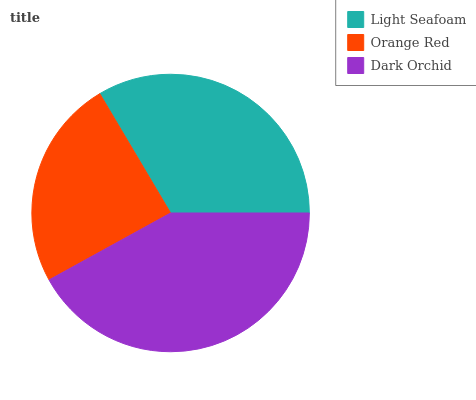Is Orange Red the minimum?
Answer yes or no. Yes. Is Dark Orchid the maximum?
Answer yes or no. Yes. Is Dark Orchid the minimum?
Answer yes or no. No. Is Orange Red the maximum?
Answer yes or no. No. Is Dark Orchid greater than Orange Red?
Answer yes or no. Yes. Is Orange Red less than Dark Orchid?
Answer yes or no. Yes. Is Orange Red greater than Dark Orchid?
Answer yes or no. No. Is Dark Orchid less than Orange Red?
Answer yes or no. No. Is Light Seafoam the high median?
Answer yes or no. Yes. Is Light Seafoam the low median?
Answer yes or no. Yes. Is Dark Orchid the high median?
Answer yes or no. No. Is Dark Orchid the low median?
Answer yes or no. No. 